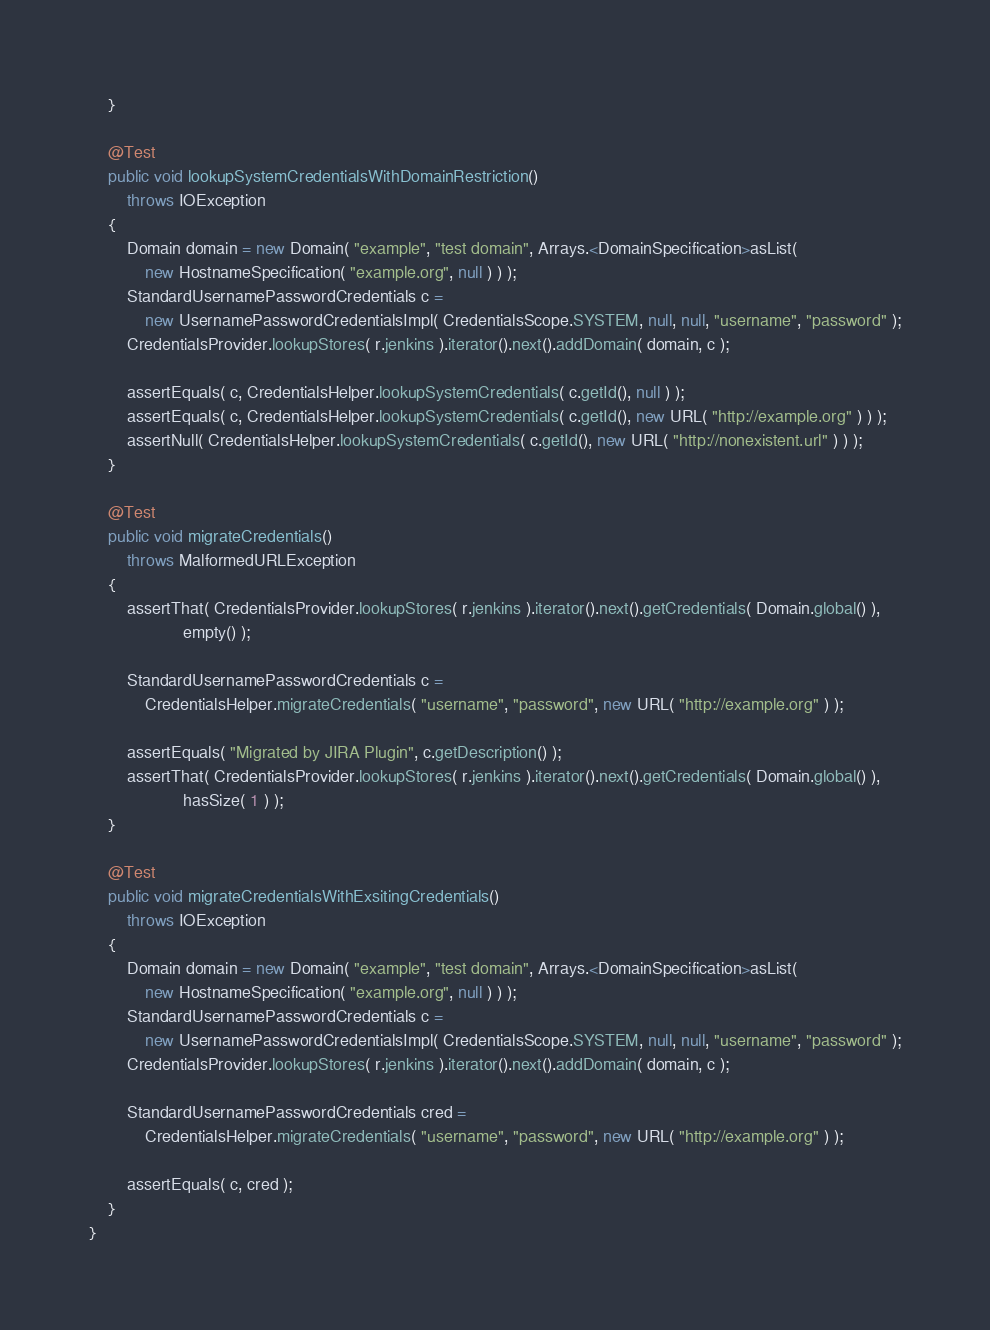<code> <loc_0><loc_0><loc_500><loc_500><_Java_>    }

    @Test
    public void lookupSystemCredentialsWithDomainRestriction()
        throws IOException
    {
        Domain domain = new Domain( "example", "test domain", Arrays.<DomainSpecification>asList(
            new HostnameSpecification( "example.org", null ) ) );
        StandardUsernamePasswordCredentials c =
            new UsernamePasswordCredentialsImpl( CredentialsScope.SYSTEM, null, null, "username", "password" );
        CredentialsProvider.lookupStores( r.jenkins ).iterator().next().addDomain( domain, c );

        assertEquals( c, CredentialsHelper.lookupSystemCredentials( c.getId(), null ) );
        assertEquals( c, CredentialsHelper.lookupSystemCredentials( c.getId(), new URL( "http://example.org" ) ) );
        assertNull( CredentialsHelper.lookupSystemCredentials( c.getId(), new URL( "http://nonexistent.url" ) ) );
    }

    @Test
    public void migrateCredentials()
        throws MalformedURLException
    {
        assertThat( CredentialsProvider.lookupStores( r.jenkins ).iterator().next().getCredentials( Domain.global() ),
                    empty() );

        StandardUsernamePasswordCredentials c =
            CredentialsHelper.migrateCredentials( "username", "password", new URL( "http://example.org" ) );

        assertEquals( "Migrated by JIRA Plugin", c.getDescription() );
        assertThat( CredentialsProvider.lookupStores( r.jenkins ).iterator().next().getCredentials( Domain.global() ),
                    hasSize( 1 ) );
    }

    @Test
    public void migrateCredentialsWithExsitingCredentials()
        throws IOException
    {
        Domain domain = new Domain( "example", "test domain", Arrays.<DomainSpecification>asList(
            new HostnameSpecification( "example.org", null ) ) );
        StandardUsernamePasswordCredentials c =
            new UsernamePasswordCredentialsImpl( CredentialsScope.SYSTEM, null, null, "username", "password" );
        CredentialsProvider.lookupStores( r.jenkins ).iterator().next().addDomain( domain, c );

        StandardUsernamePasswordCredentials cred =
            CredentialsHelper.migrateCredentials( "username", "password", new URL( "http://example.org" ) );

        assertEquals( c, cred );
    }
}
</code> 